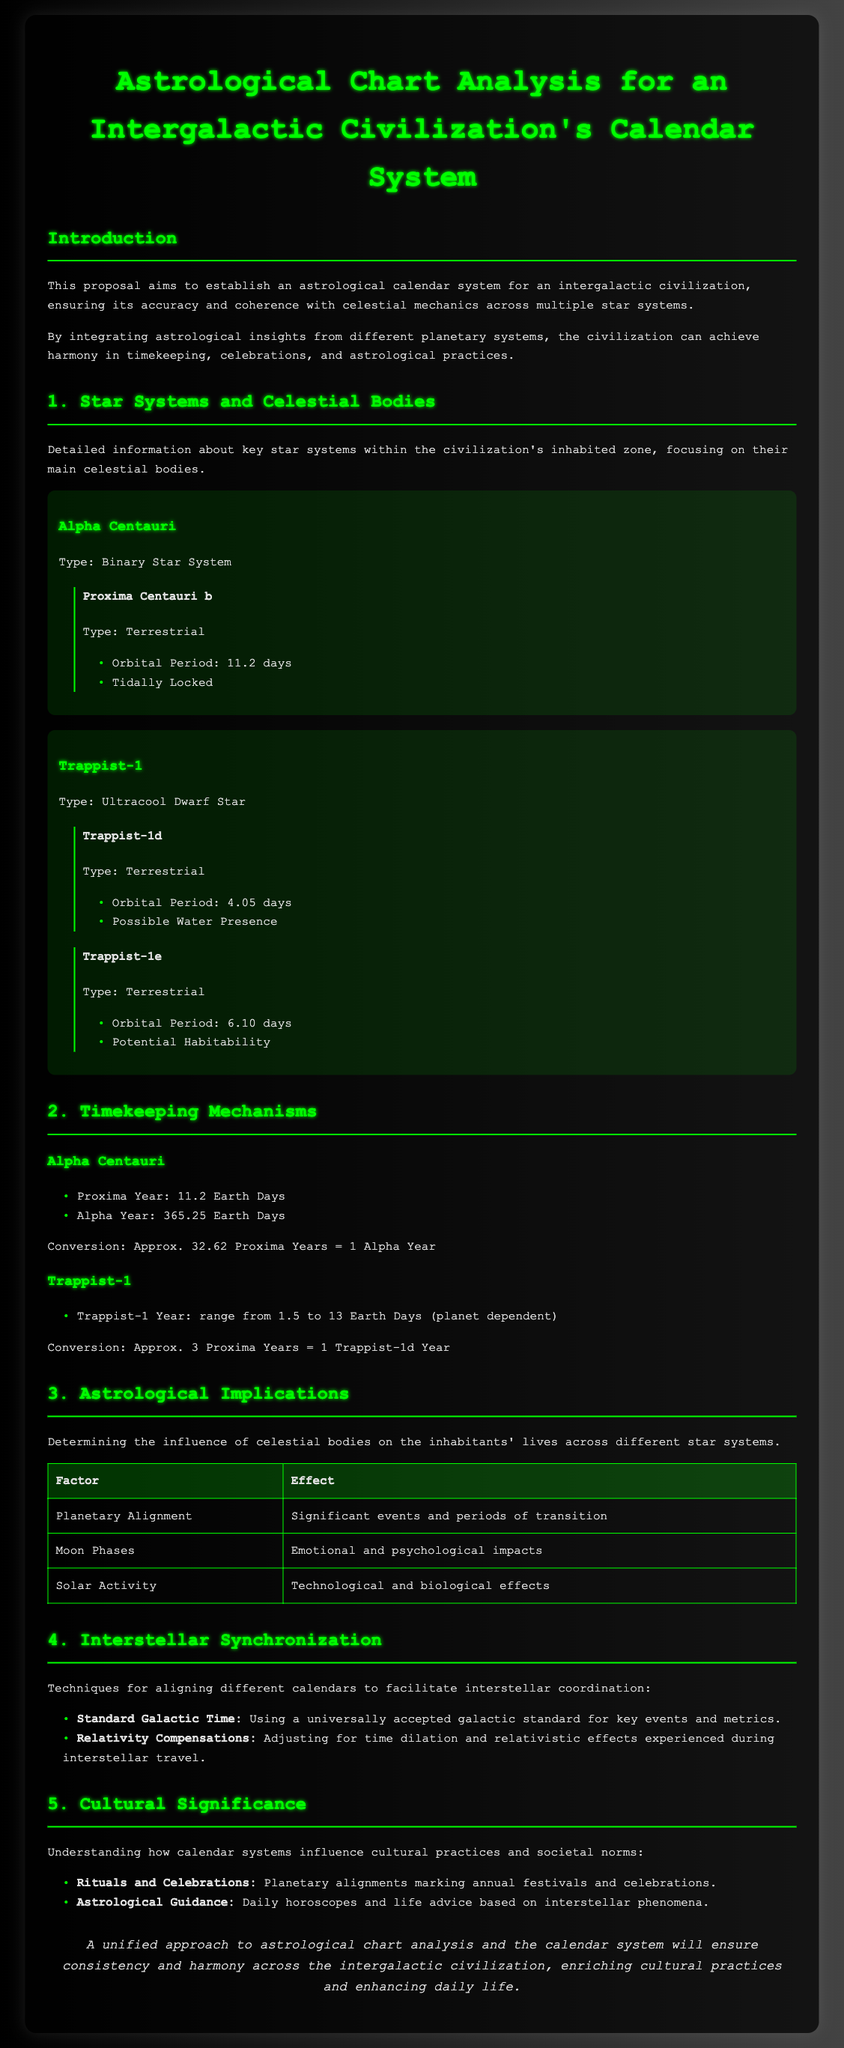what is the title of the proposal? The title of the proposal is the main heading of the document and indicates its purpose.
Answer: Astrological Chart Analysis for an Intergalactic Civilization's Calendar System how many days is a Proxima Year? This information is stated in the section discussing timekeeping mechanisms for Alpha Centauri.
Answer: 11.2 Earth Days what type of star system is Trappist-1? The type of Trappist-1 is described in the document under the star systems section.
Answer: Ultracool Dwarf Star what is the orbital period of Trappist-1d? The orbital period is specified in the details for the planet Trappist-1d, providing specific astrological information.
Answer: 4.05 days how are planetary alignments significant? This question pertains to the effects noted in the section on astrological implications dealing with significant events.
Answer: Significant events and periods of transition what is the range of a Trappist-1 Year? This information is found in the timekeeping section describing the variability of years in the Trappist-1 system.
Answer: range from 1.5 to 13 Earth Days what does Standard Galactic Time refer to? This term is mentioned in the interstellar synchronization section, relating to coordination across star systems.
Answer: A universally accepted galactic standard how does the proposal enhance daily life? The conclusion discusses the overall impact of this proposal on cultural practices and everyday activities.
Answer: Ensures consistency and harmony what are some cultural practices influenced by the calendar systems? This detail is captured in the section discussing cultural significance, focusing on rituals and horoscopes.
Answer: Rituals and Celebrations, Astrological Guidance 